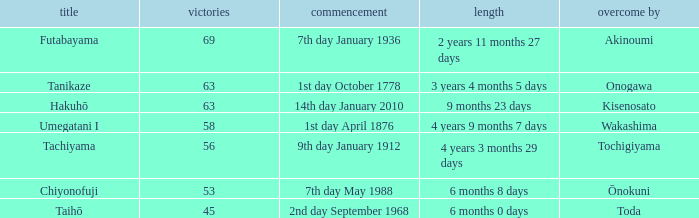What is the Duration for less than 53 consecutive wins? 6 months 0 days. 